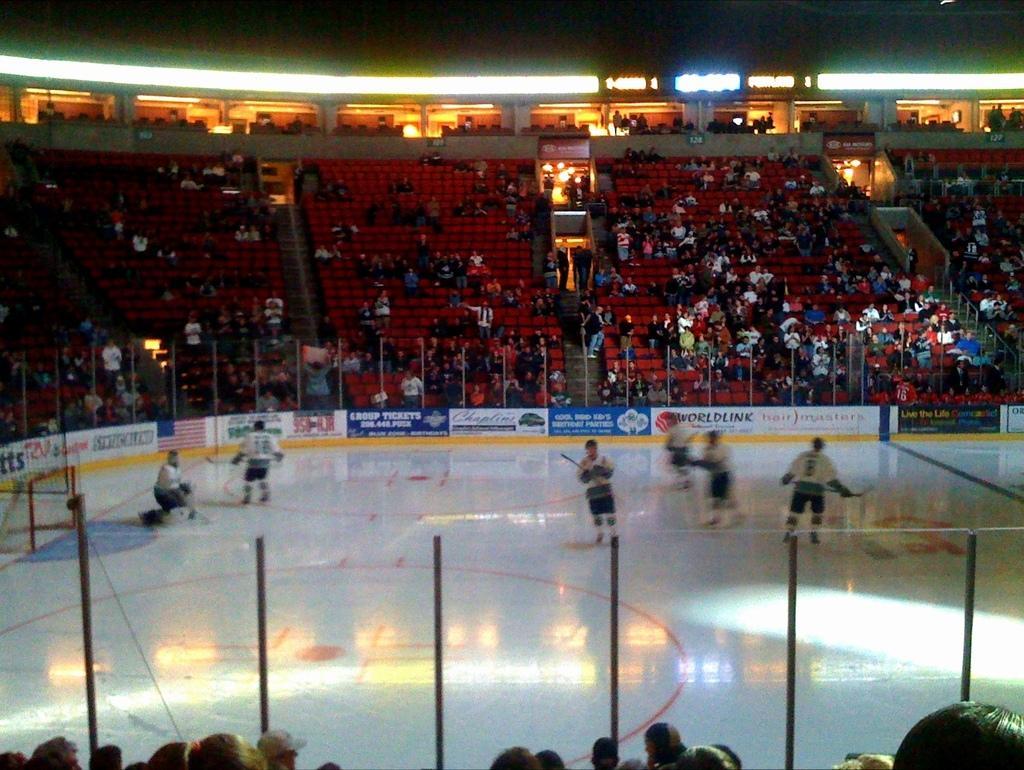How would you summarize this image in a sentence or two? In this picture we can see a group of people where some are sitting on chairs and some are standing on the ground and holding bats with their hands, banners, fence, net and in the background we can see the lights. 